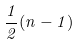Convert formula to latex. <formula><loc_0><loc_0><loc_500><loc_500>\frac { 1 } { 2 } ( n - 1 )</formula> 